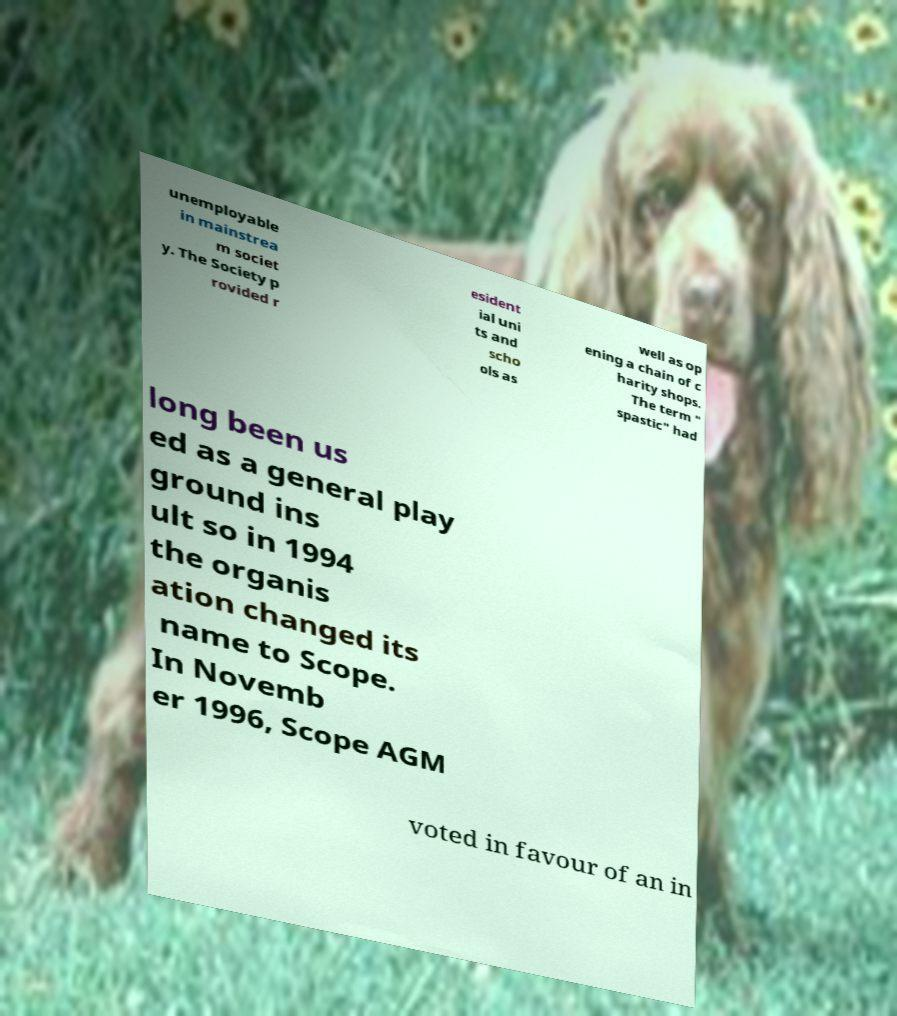Please read and relay the text visible in this image. What does it say? unemployable in mainstrea m societ y. The Society p rovided r esident ial uni ts and scho ols as well as op ening a chain of c harity shops. The term " spastic" had long been us ed as a general play ground ins ult so in 1994 the organis ation changed its name to Scope. In Novemb er 1996, Scope AGM voted in favour of an in 